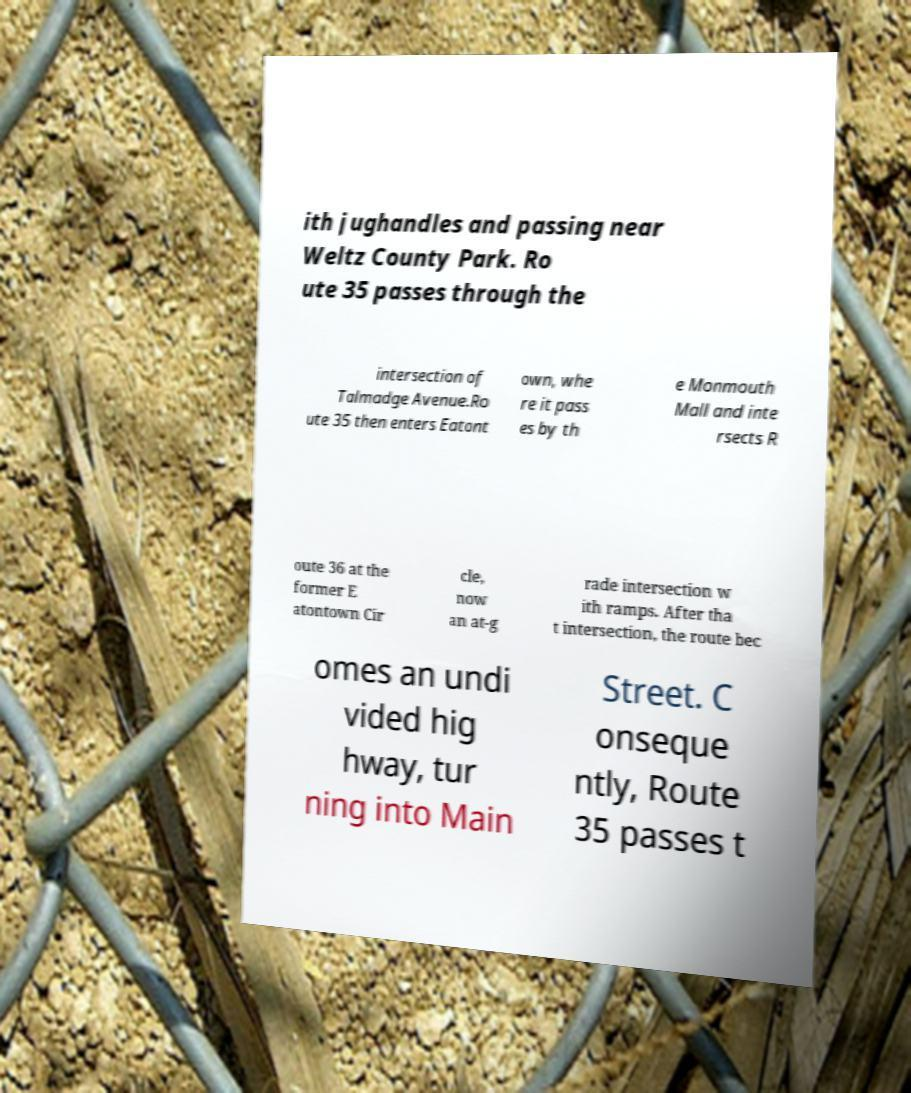What messages or text are displayed in this image? I need them in a readable, typed format. ith jughandles and passing near Weltz County Park. Ro ute 35 passes through the intersection of Talmadge Avenue.Ro ute 35 then enters Eatont own, whe re it pass es by th e Monmouth Mall and inte rsects R oute 36 at the former E atontown Cir cle, now an at-g rade intersection w ith ramps. After tha t intersection, the route bec omes an undi vided hig hway, tur ning into Main Street. C onseque ntly, Route 35 passes t 